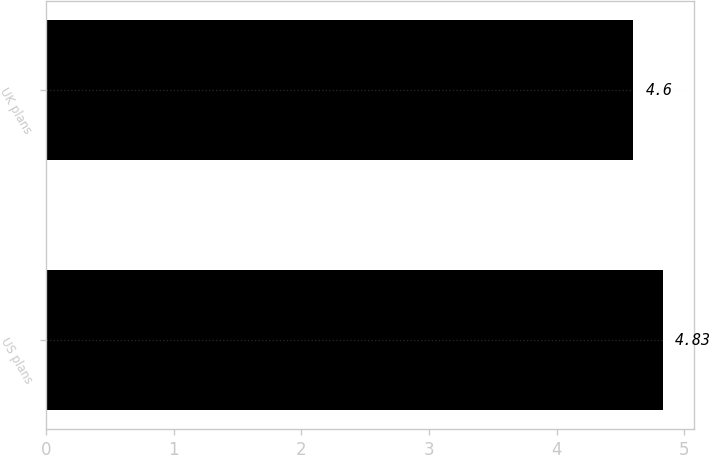<chart> <loc_0><loc_0><loc_500><loc_500><bar_chart><fcel>US plans<fcel>UK plans<nl><fcel>4.83<fcel>4.6<nl></chart> 